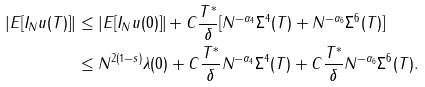<formula> <loc_0><loc_0><loc_500><loc_500>| E [ I _ { N } u ( T ) ] | & \leq | E [ I _ { N } u ( 0 ) ] | + C \frac { T ^ { * } } { \delta } [ N ^ { - \alpha _ { 4 } } \Sigma ^ { 4 } ( T ) + N ^ { - \alpha _ { 6 } } \Sigma ^ { 6 } ( T ) ] \\ & \leq N ^ { 2 ( 1 - s ) } \lambda ( 0 ) + C \frac { T ^ { * } } { \delta } N ^ { - \alpha _ { 4 } } \Sigma ^ { 4 } ( T ) + C \frac { T ^ { * } } { \delta } N ^ { - \alpha _ { 6 } } \Sigma ^ { 6 } ( T ) .</formula> 